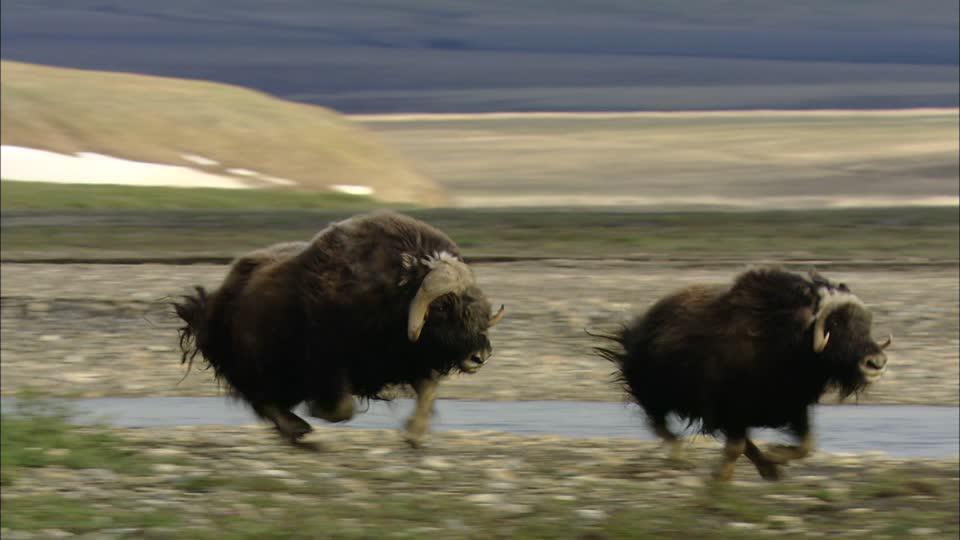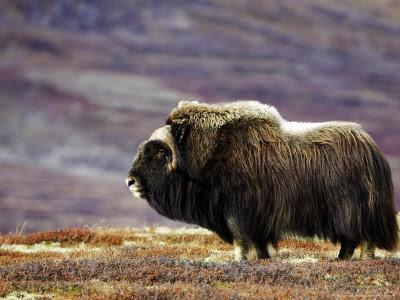The first image is the image on the left, the second image is the image on the right. Assess this claim about the two images: "Buffalo are in a fanned-out circle formation, each animal looking outward, in at least one image.". Correct or not? Answer yes or no. No. The first image is the image on the left, the second image is the image on the right. Considering the images on both sides, is "There are buffalo standing in snow." valid? Answer yes or no. No. 